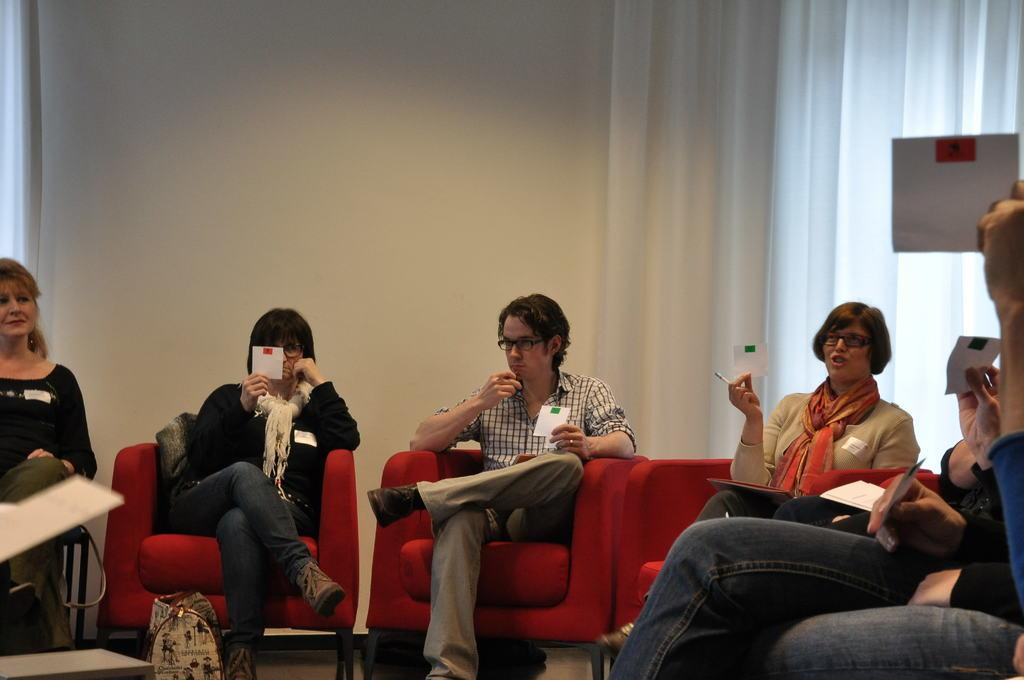What is happening in the image involving a group of people? There is a group of people in the image, and they are seated on chairs. What are the people holding in their hands? The people are holding papers in their hands. Can you describe the floor in the image? There is a bag on the floor in the image. What is present near the window in the image? There is a curtain associated with the window. What color is the background wall in the image? The background wall is white. How many tomatoes are on the table in the image? There are no tomatoes present in the image. What idea did the people come up with during their meeting in the image? The image does not provide any information about the people's ideas or discussions. 